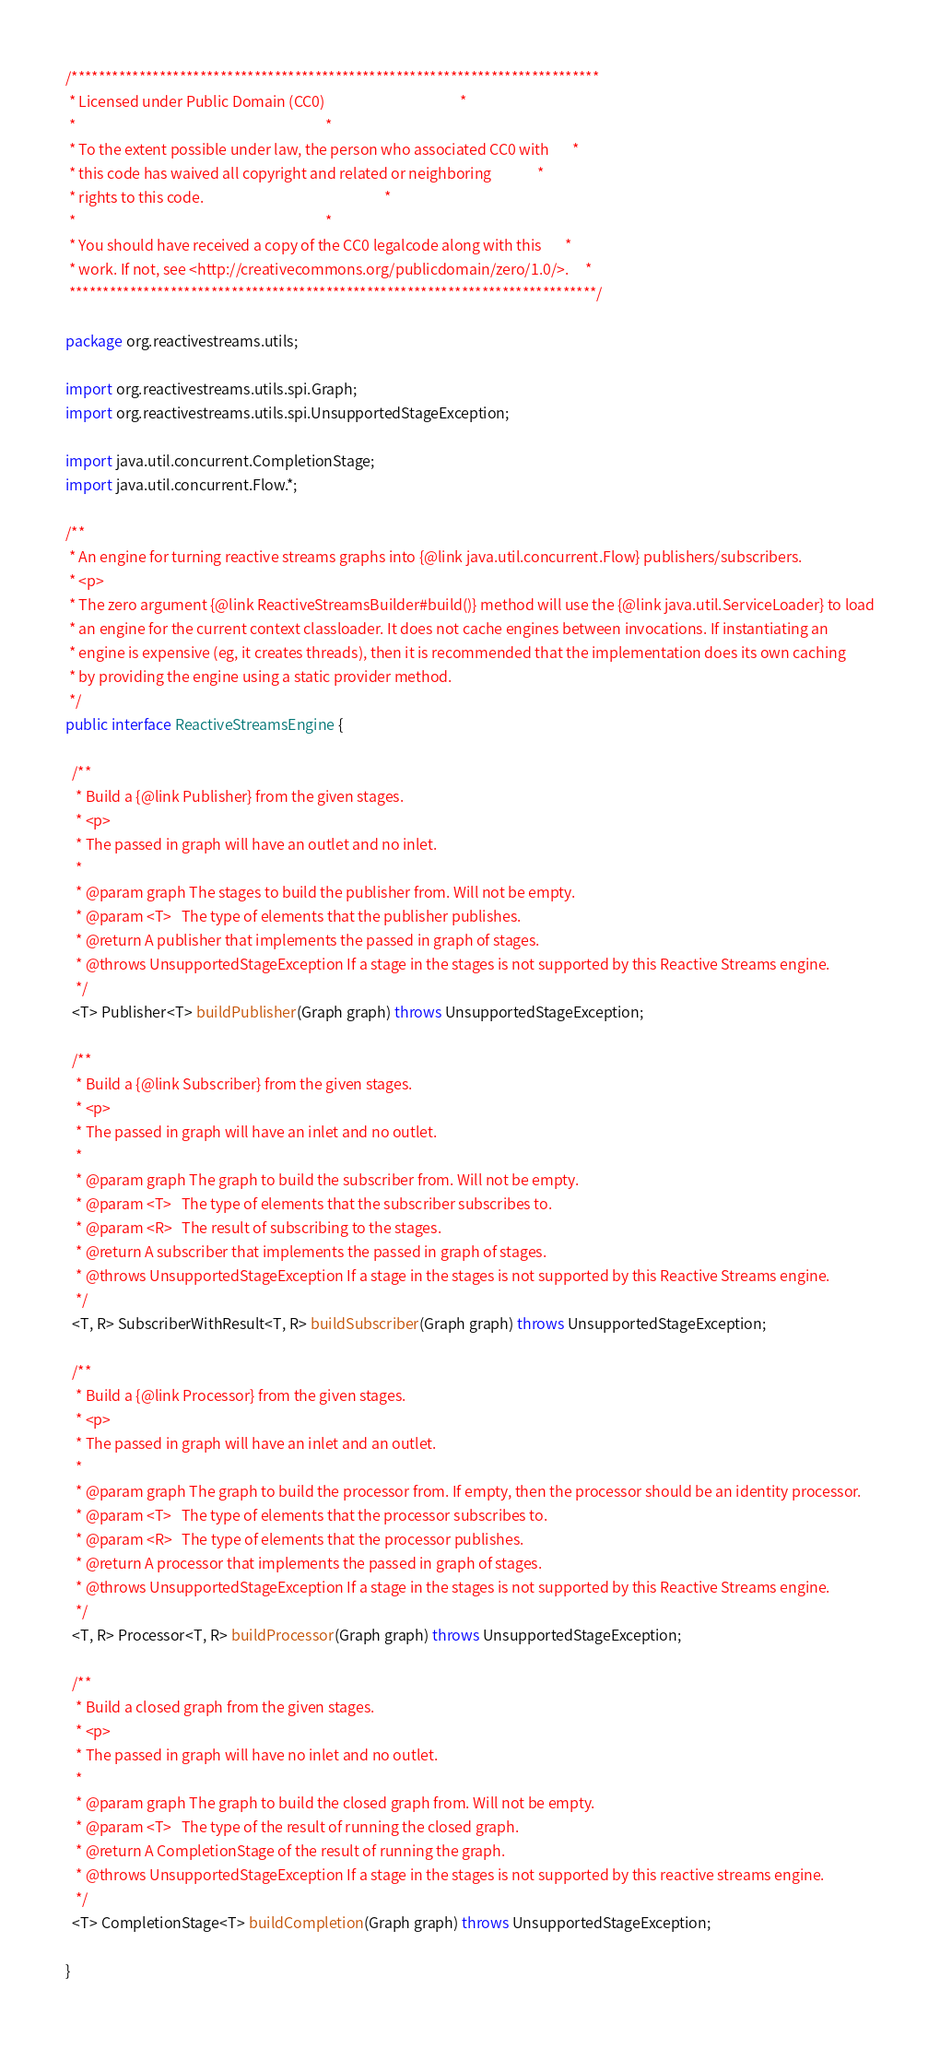Convert code to text. <code><loc_0><loc_0><loc_500><loc_500><_Java_>/******************************************************************************
 * Licensed under Public Domain (CC0)                                         *
 *                                                                            *
 * To the extent possible under law, the person who associated CC0 with       *
 * this code has waived all copyright and related or neighboring              *
 * rights to this code.                                                       *
 *                                                                            *
 * You should have received a copy of the CC0 legalcode along with this       *
 * work. If not, see <http://creativecommons.org/publicdomain/zero/1.0/>.     *
 ******************************************************************************/

package org.reactivestreams.utils;

import org.reactivestreams.utils.spi.Graph;
import org.reactivestreams.utils.spi.UnsupportedStageException;

import java.util.concurrent.CompletionStage;
import java.util.concurrent.Flow.*;

/**
 * An engine for turning reactive streams graphs into {@link java.util.concurrent.Flow} publishers/subscribers.
 * <p>
 * The zero argument {@link ReactiveStreamsBuilder#build()} method will use the {@link java.util.ServiceLoader} to load
 * an engine for the current context classloader. It does not cache engines between invocations. If instantiating an
 * engine is expensive (eg, it creates threads), then it is recommended that the implementation does its own caching
 * by providing the engine using a static provider method.
 */
public interface ReactiveStreamsEngine {

  /**
   * Build a {@link Publisher} from the given stages.
   * <p>
   * The passed in graph will have an outlet and no inlet.
   *
   * @param graph The stages to build the publisher from. Will not be empty.
   * @param <T>   The type of elements that the publisher publishes.
   * @return A publisher that implements the passed in graph of stages.
   * @throws UnsupportedStageException If a stage in the stages is not supported by this Reactive Streams engine.
   */
  <T> Publisher<T> buildPublisher(Graph graph) throws UnsupportedStageException;

  /**
   * Build a {@link Subscriber} from the given stages.
   * <p>
   * The passed in graph will have an inlet and no outlet.
   *
   * @param graph The graph to build the subscriber from. Will not be empty.
   * @param <T>   The type of elements that the subscriber subscribes to.
   * @param <R>   The result of subscribing to the stages.
   * @return A subscriber that implements the passed in graph of stages.
   * @throws UnsupportedStageException If a stage in the stages is not supported by this Reactive Streams engine.
   */
  <T, R> SubscriberWithResult<T, R> buildSubscriber(Graph graph) throws UnsupportedStageException;

  /**
   * Build a {@link Processor} from the given stages.
   * <p>
   * The passed in graph will have an inlet and an outlet.
   *
   * @param graph The graph to build the processor from. If empty, then the processor should be an identity processor.
   * @param <T>   The type of elements that the processor subscribes to.
   * @param <R>   The type of elements that the processor publishes.
   * @return A processor that implements the passed in graph of stages.
   * @throws UnsupportedStageException If a stage in the stages is not supported by this Reactive Streams engine.
   */
  <T, R> Processor<T, R> buildProcessor(Graph graph) throws UnsupportedStageException;

  /**
   * Build a closed graph from the given stages.
   * <p>
   * The passed in graph will have no inlet and no outlet.
   *
   * @param graph The graph to build the closed graph from. Will not be empty.
   * @param <T>   The type of the result of running the closed graph.
   * @return A CompletionStage of the result of running the graph.
   * @throws UnsupportedStageException If a stage in the stages is not supported by this reactive streams engine.
   */
  <T> CompletionStage<T> buildCompletion(Graph graph) throws UnsupportedStageException;

}
</code> 